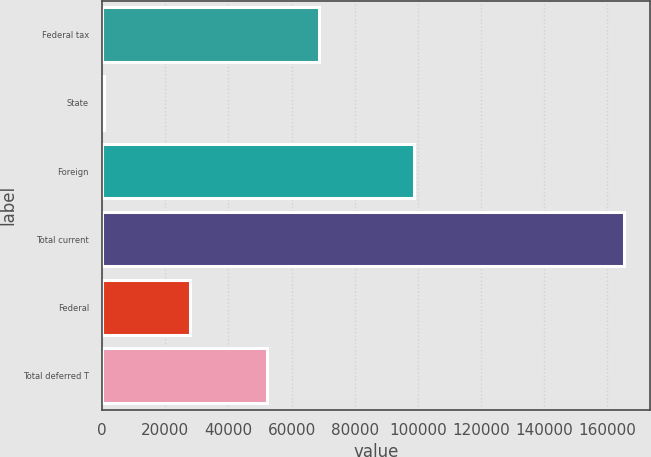Convert chart to OTSL. <chart><loc_0><loc_0><loc_500><loc_500><bar_chart><fcel>Federal tax<fcel>State<fcel>Foreign<fcel>Total current<fcel>Federal<fcel>Total deferred T<nl><fcel>68689.5<fcel>695<fcel>98813<fcel>165450<fcel>27933<fcel>52214<nl></chart> 